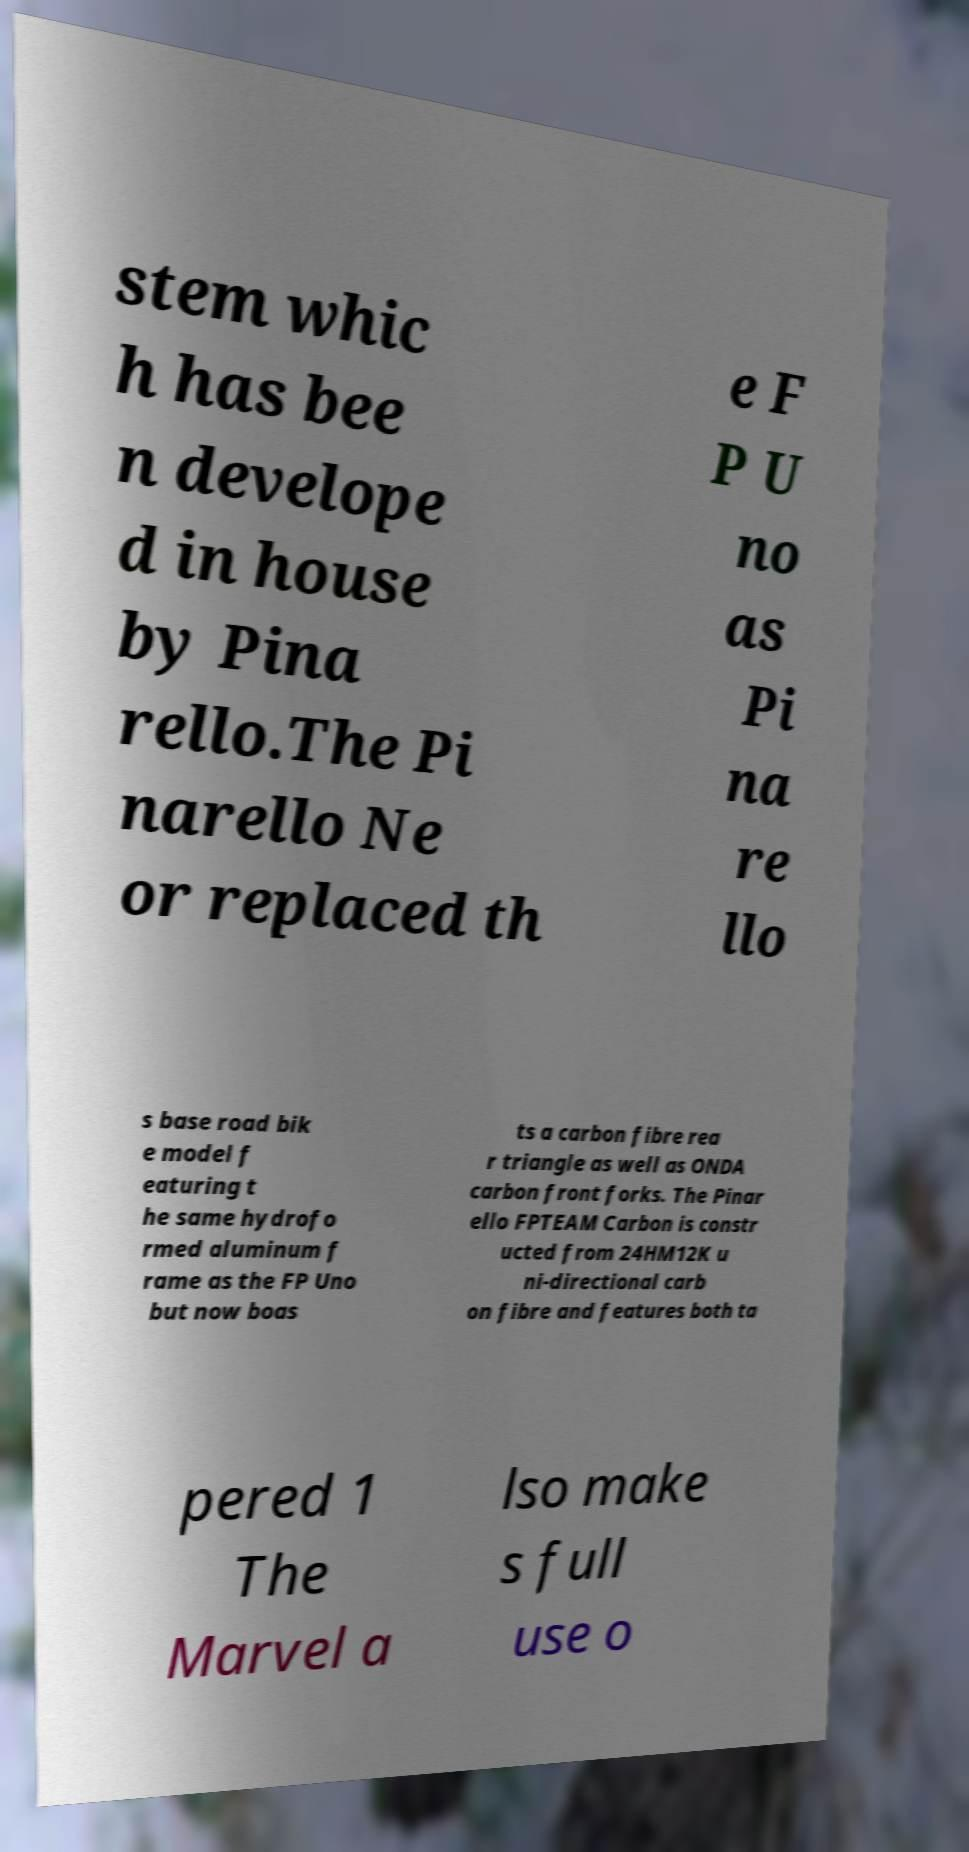Can you accurately transcribe the text from the provided image for me? stem whic h has bee n develope d in house by Pina rello.The Pi narello Ne or replaced th e F P U no as Pi na re llo s base road bik e model f eaturing t he same hydrofo rmed aluminum f rame as the FP Uno but now boas ts a carbon fibre rea r triangle as well as ONDA carbon front forks. The Pinar ello FPTEAM Carbon is constr ucted from 24HM12K u ni-directional carb on fibre and features both ta pered 1 The Marvel a lso make s full use o 